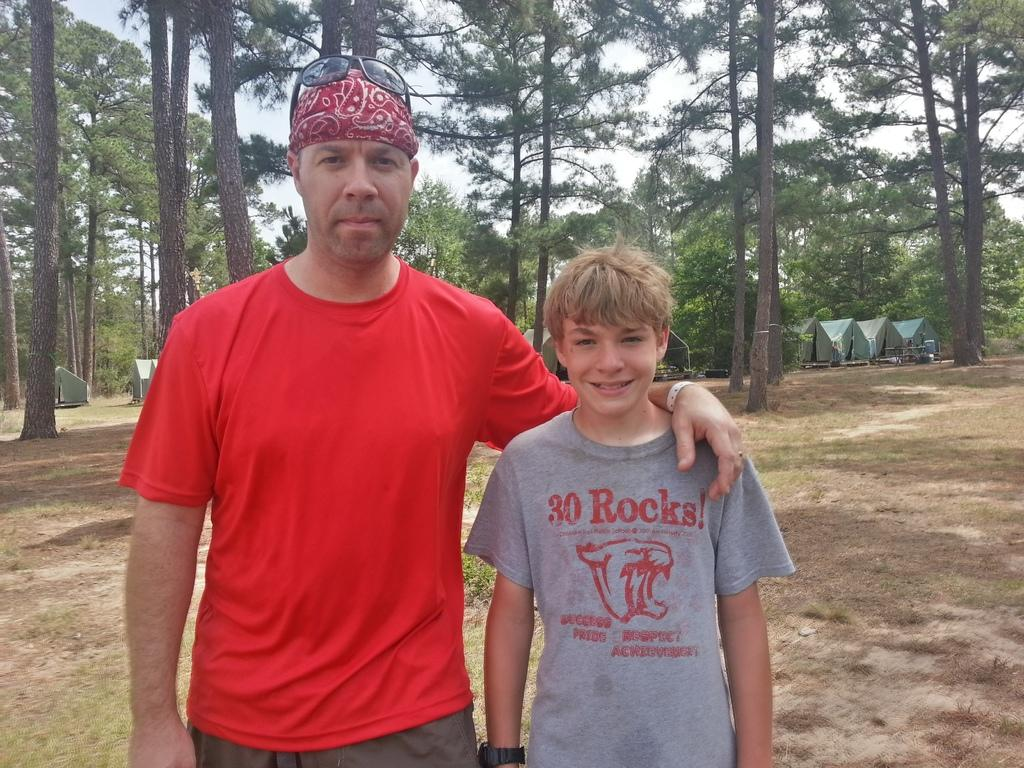How many people are in the image? There are two people standing in the center of the image. What can be seen in the background of the image? There are trees in the background of the image. What type of structures are present in the image? There are tents in the image. What type of ground is visible in the image? There is grass at the bottom of the image. Can you see the grandfather's thumb in the image? There is no mention of a grandfather or a thumb in the image, so it cannot be determined if the grandfather's thumb is visible. 